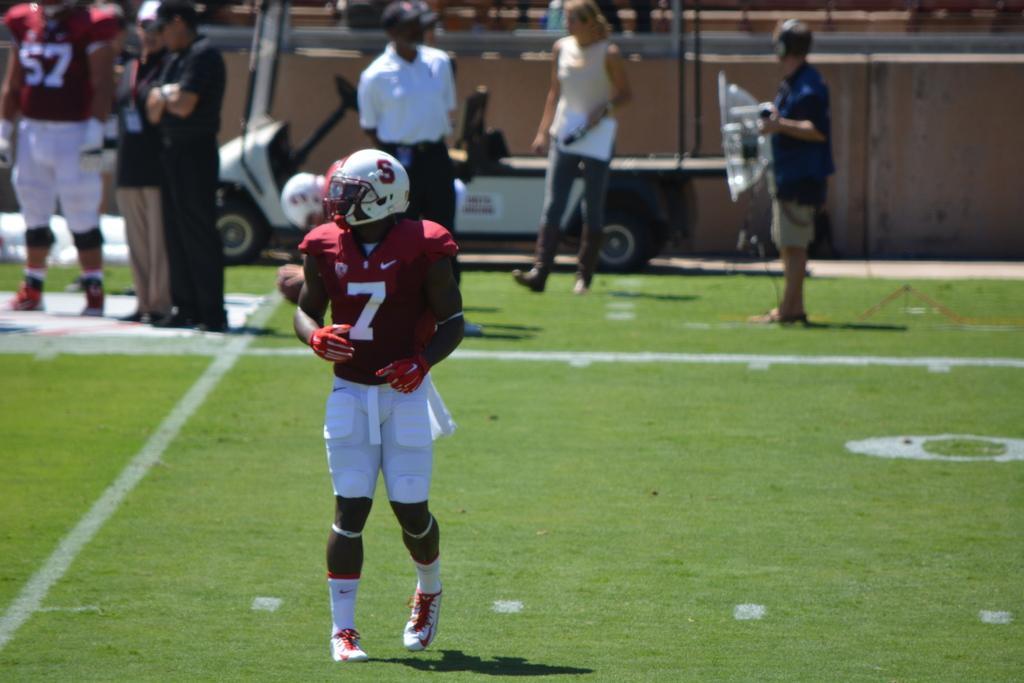Can you describe this image briefly? In this image I can see a person wearing helmet is standing in the ground at the back there are group of people standing in-front of vehicle also there is a wall. 